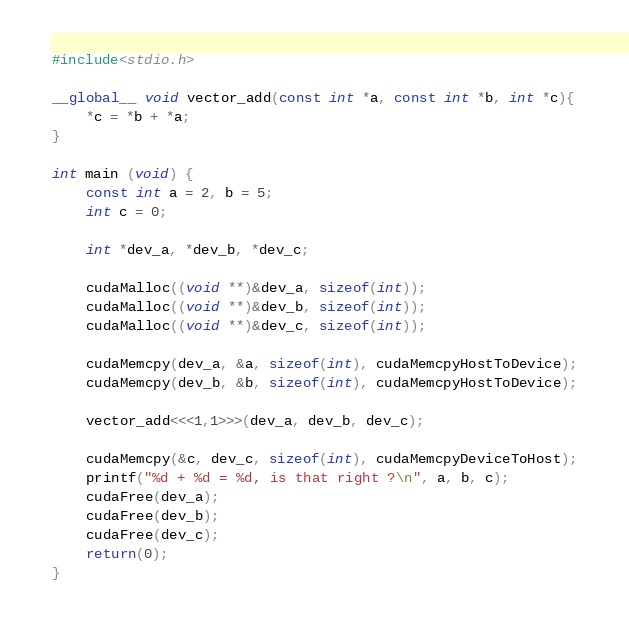<code> <loc_0><loc_0><loc_500><loc_500><_Cuda_>#include<stdio.h>

__global__ void vector_add(const int *a, const int *b, int *c){
	*c = *b + *a;
}

int main (void) {
	const int a = 2, b = 5;
	int c = 0;

	int *dev_a, *dev_b, *dev_c;

	cudaMalloc((void **)&dev_a, sizeof(int));
	cudaMalloc((void **)&dev_b, sizeof(int));
	cudaMalloc((void **)&dev_c, sizeof(int));
	
	cudaMemcpy(dev_a, &a, sizeof(int), cudaMemcpyHostToDevice);
	cudaMemcpy(dev_b, &b, sizeof(int), cudaMemcpyHostToDevice);

	vector_add<<<1,1>>>(dev_a, dev_b, dev_c);
	
	cudaMemcpy(&c, dev_c, sizeof(int), cudaMemcpyDeviceToHost);
	printf("%d + %d = %d, is that right ?\n", a, b, c);
	cudaFree(dev_a);
	cudaFree(dev_b);
	cudaFree(dev_c);
	return(0);
}

</code> 